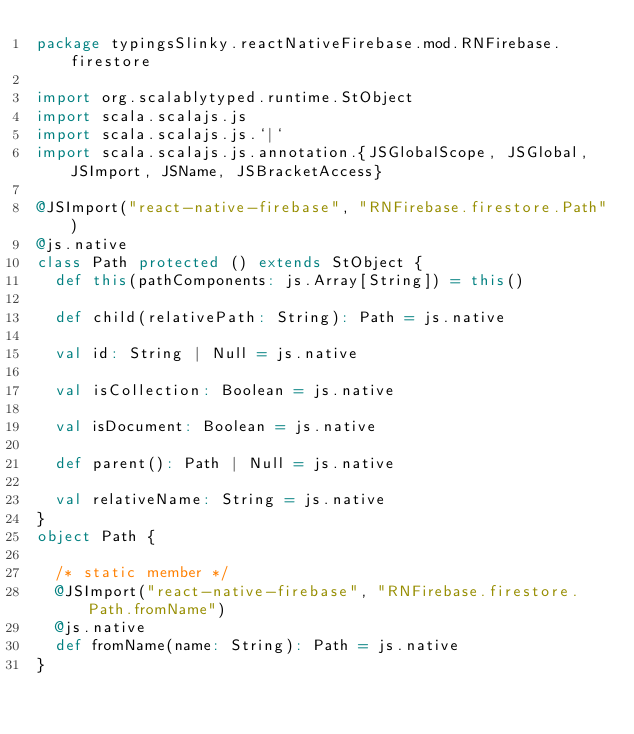Convert code to text. <code><loc_0><loc_0><loc_500><loc_500><_Scala_>package typingsSlinky.reactNativeFirebase.mod.RNFirebase.firestore

import org.scalablytyped.runtime.StObject
import scala.scalajs.js
import scala.scalajs.js.`|`
import scala.scalajs.js.annotation.{JSGlobalScope, JSGlobal, JSImport, JSName, JSBracketAccess}

@JSImport("react-native-firebase", "RNFirebase.firestore.Path")
@js.native
class Path protected () extends StObject {
  def this(pathComponents: js.Array[String]) = this()
  
  def child(relativePath: String): Path = js.native
  
  val id: String | Null = js.native
  
  val isCollection: Boolean = js.native
  
  val isDocument: Boolean = js.native
  
  def parent(): Path | Null = js.native
  
  val relativeName: String = js.native
}
object Path {
  
  /* static member */
  @JSImport("react-native-firebase", "RNFirebase.firestore.Path.fromName")
  @js.native
  def fromName(name: String): Path = js.native
}
</code> 